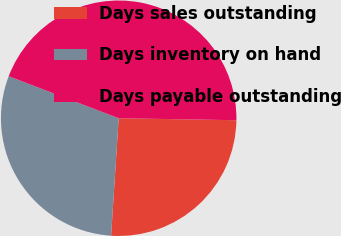Convert chart. <chart><loc_0><loc_0><loc_500><loc_500><pie_chart><fcel>Days sales outstanding<fcel>Days inventory on hand<fcel>Days payable outstanding<nl><fcel>25.76%<fcel>29.78%<fcel>44.46%<nl></chart> 